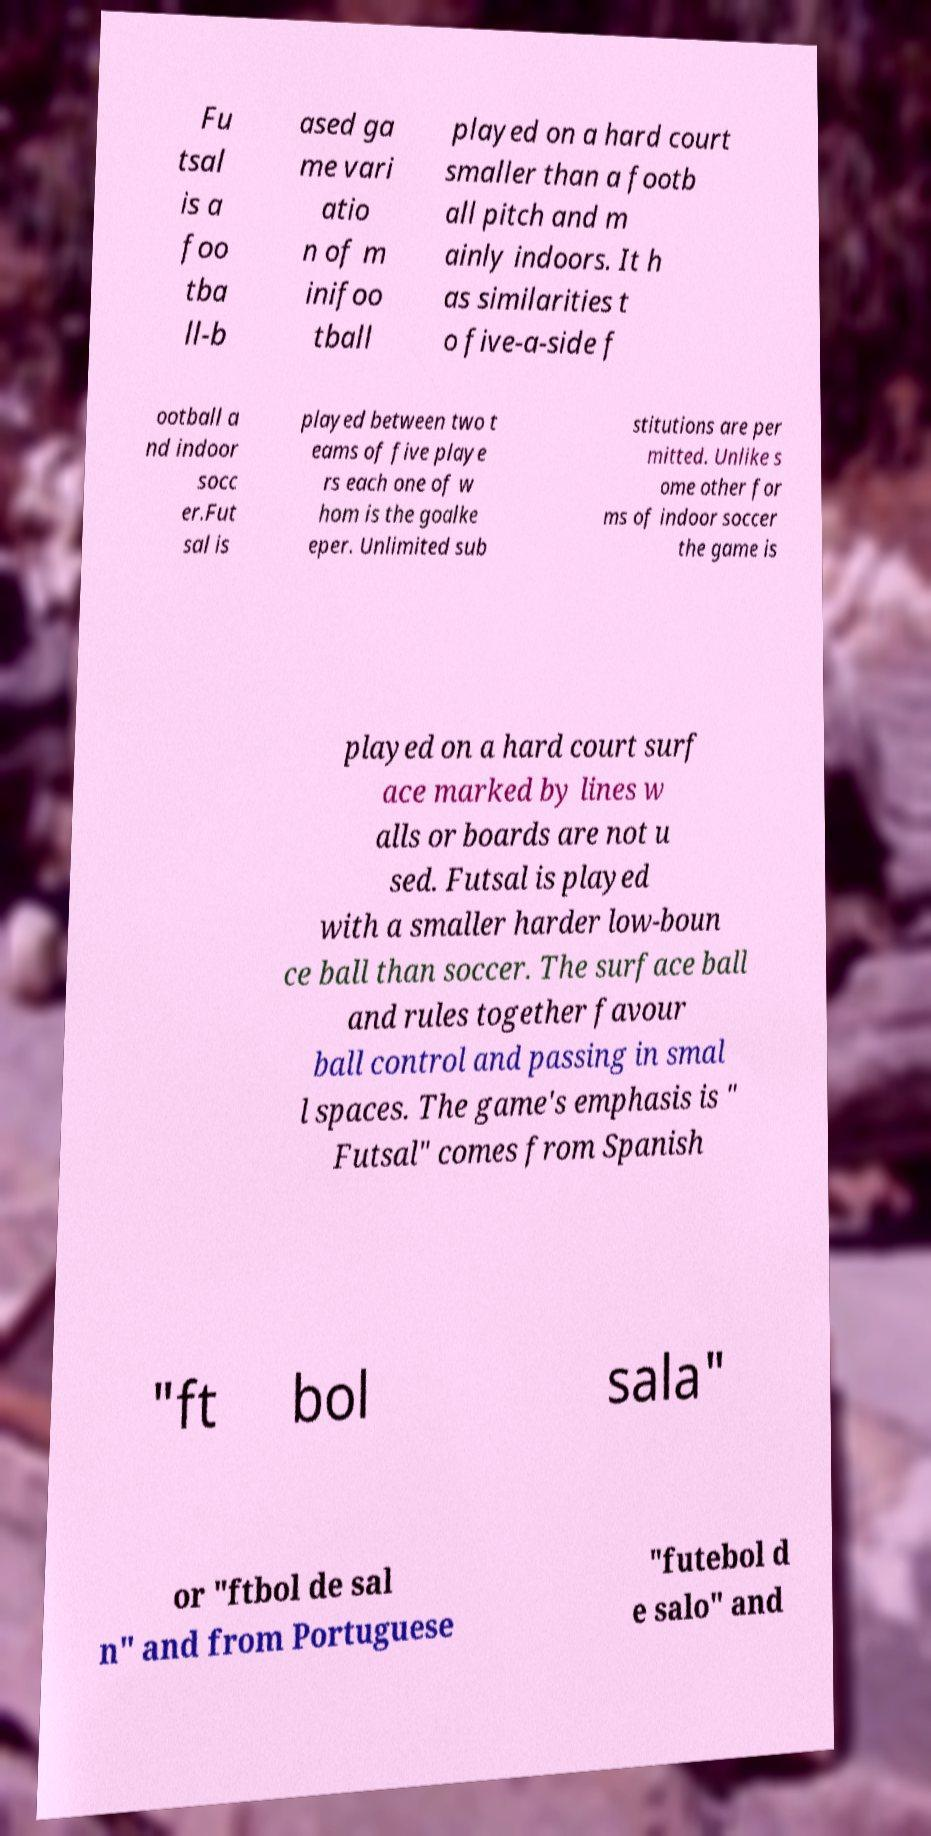Could you extract and type out the text from this image? Fu tsal is a foo tba ll-b ased ga me vari atio n of m inifoo tball played on a hard court smaller than a footb all pitch and m ainly indoors. It h as similarities t o five-a-side f ootball a nd indoor socc er.Fut sal is played between two t eams of five playe rs each one of w hom is the goalke eper. Unlimited sub stitutions are per mitted. Unlike s ome other for ms of indoor soccer the game is played on a hard court surf ace marked by lines w alls or boards are not u sed. Futsal is played with a smaller harder low-boun ce ball than soccer. The surface ball and rules together favour ball control and passing in smal l spaces. The game's emphasis is " Futsal" comes from Spanish "ft bol sala" or "ftbol de sal n" and from Portuguese "futebol d e salo" and 